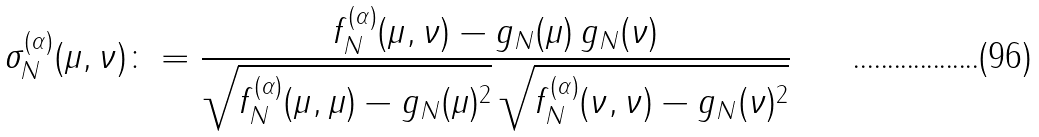<formula> <loc_0><loc_0><loc_500><loc_500>\sigma ^ { ( \alpha ) } _ { N } ( \mu , \nu ) & \colon = \frac { f ^ { ( \alpha ) } _ { N } ( \mu , \nu ) - g _ { N } ( \mu ) \, g _ { N } ( \nu ) } { \sqrt { f ^ { ( \alpha ) } _ { N } ( \mu , \mu ) - g _ { N } ( \mu ) ^ { 2 } } \, \sqrt { f ^ { ( \alpha ) } _ { N } ( \nu , \nu ) - g _ { N } ( \nu ) ^ { 2 } } }</formula> 